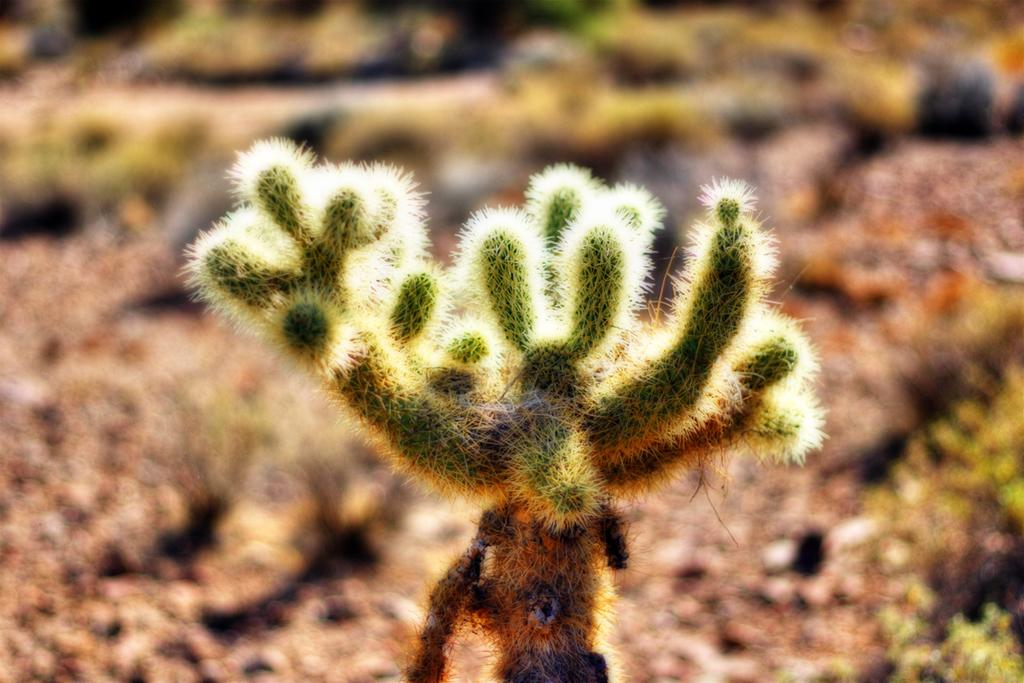What type of plant is present in the image? There is a cactus in the image. What type of blood is visible on the cactus in the image? There is no blood visible on the cactus in the image. How much sugar is present on the cactus in the image? There is no sugar present on the cactus in the image. 